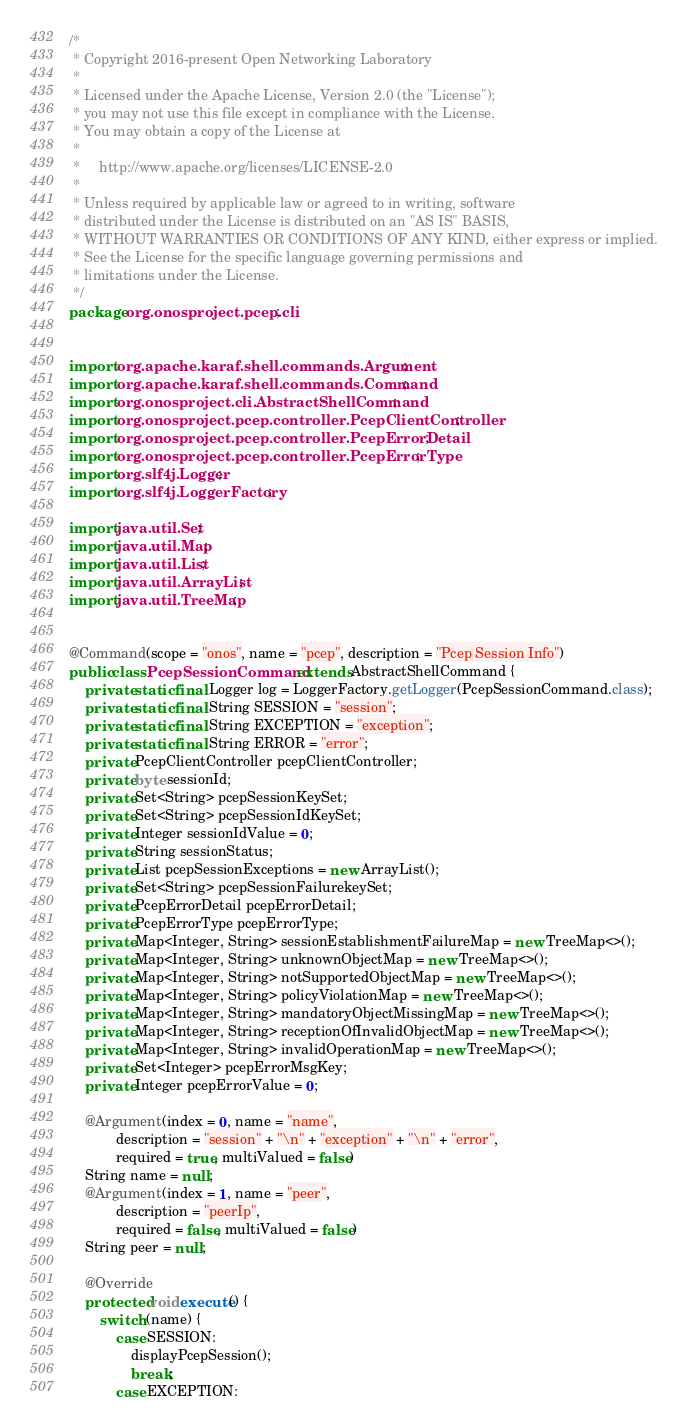Convert code to text. <code><loc_0><loc_0><loc_500><loc_500><_Java_>/*
 * Copyright 2016-present Open Networking Laboratory
 *
 * Licensed under the Apache License, Version 2.0 (the "License");
 * you may not use this file except in compliance with the License.
 * You may obtain a copy of the License at
 *
 *     http://www.apache.org/licenses/LICENSE-2.0
 *
 * Unless required by applicable law or agreed to in writing, software
 * distributed under the License is distributed on an "AS IS" BASIS,
 * WITHOUT WARRANTIES OR CONDITIONS OF ANY KIND, either express or implied.
 * See the License for the specific language governing permissions and
 * limitations under the License.
 */
package org.onosproject.pcep.cli;


import org.apache.karaf.shell.commands.Argument;
import org.apache.karaf.shell.commands.Command;
import org.onosproject.cli.AbstractShellCommand;
import org.onosproject.pcep.controller.PcepClientController;
import org.onosproject.pcep.controller.PcepErrorDetail;
import org.onosproject.pcep.controller.PcepErrorType;
import org.slf4j.Logger;
import org.slf4j.LoggerFactory;

import java.util.Set;
import java.util.Map;
import java.util.List;
import java.util.ArrayList;
import java.util.TreeMap;


@Command(scope = "onos", name = "pcep", description = "Pcep Session Info")
public class PcepSessionCommand extends AbstractShellCommand {
    private static final Logger log = LoggerFactory.getLogger(PcepSessionCommand.class);
    private static final String SESSION = "session";
    private static final String EXCEPTION = "exception";
    private static final String ERROR = "error";
    private PcepClientController pcepClientController;
    private byte sessionId;
    private Set<String> pcepSessionKeySet;
    private Set<String> pcepSessionIdKeySet;
    private Integer sessionIdValue = 0;
    private String sessionStatus;
    private List pcepSessionExceptions = new ArrayList();
    private Set<String> pcepSessionFailurekeySet;
    private PcepErrorDetail pcepErrorDetail;
    private PcepErrorType pcepErrorType;
    private Map<Integer, String> sessionEstablishmentFailureMap = new TreeMap<>();
    private Map<Integer, String> unknownObjectMap = new TreeMap<>();
    private Map<Integer, String> notSupportedObjectMap = new TreeMap<>();
    private Map<Integer, String> policyViolationMap = new TreeMap<>();
    private Map<Integer, String> mandatoryObjectMissingMap = new TreeMap<>();
    private Map<Integer, String> receptionOfInvalidObjectMap = new TreeMap<>();
    private Map<Integer, String> invalidOperationMap = new TreeMap<>();
    private Set<Integer> pcepErrorMsgKey;
    private Integer pcepErrorValue = 0;

    @Argument(index = 0, name = "name",
            description = "session" + "\n" + "exception" + "\n" + "error",
            required = true, multiValued = false)
    String name = null;
    @Argument(index = 1, name = "peer",
            description = "peerIp",
            required = false, multiValued = false)
    String peer = null;

    @Override
    protected void execute() {
        switch (name) {
            case SESSION:
                displayPcepSession();
                break;
            case EXCEPTION:</code> 